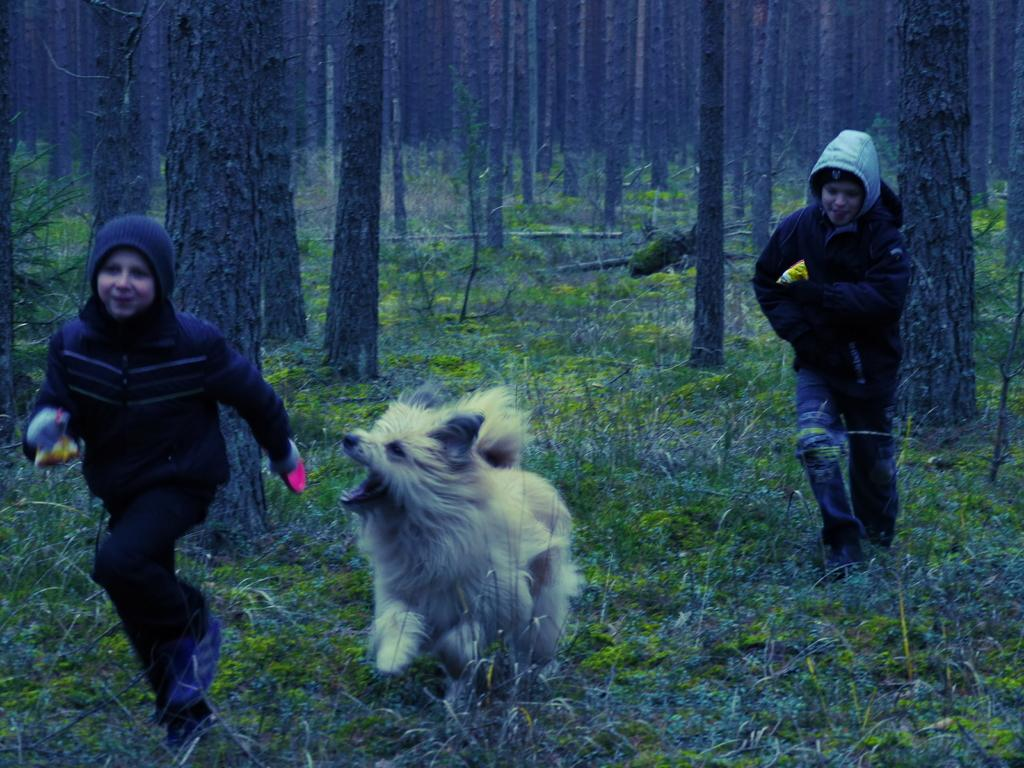How many people are in the image? There are two persons in the image. What other living creature is present in the image? There is a dog in the image. What type of terrain is visible at the bottom of the image? Grass is visible at the bottom of the image. What can be seen in the background of the image? There are trees in the background of the image. What type of pain is the dog experiencing in the image? There is no indication in the image that the dog is experiencing any pain. What system is being discussed by the two persons in the image? There is no system being discussed by the two persons in the image. 